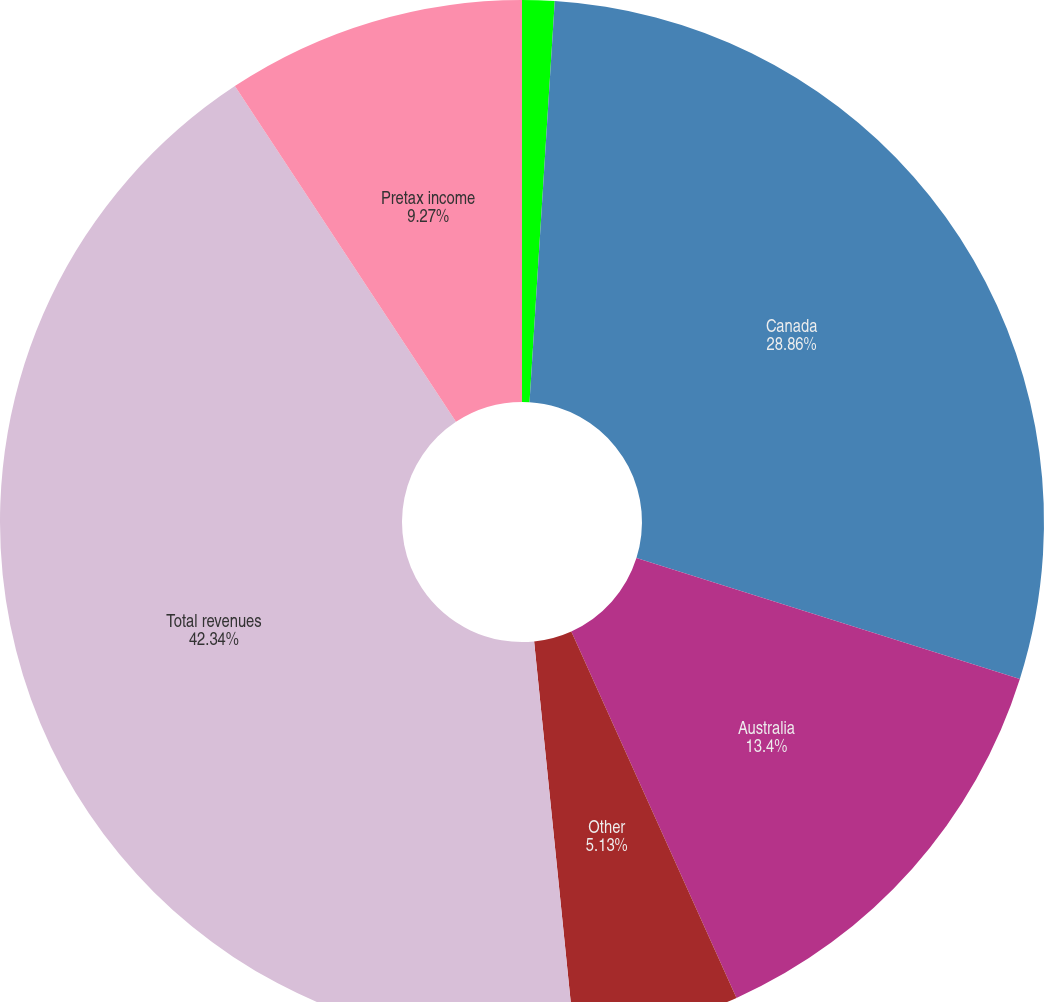Convert chart to OTSL. <chart><loc_0><loc_0><loc_500><loc_500><pie_chart><fcel>Year ended April 30<fcel>Canada<fcel>Australia<fcel>Other<fcel>Total revenues<fcel>Pretax income<nl><fcel>1.0%<fcel>28.86%<fcel>13.4%<fcel>5.13%<fcel>42.34%<fcel>9.27%<nl></chart> 